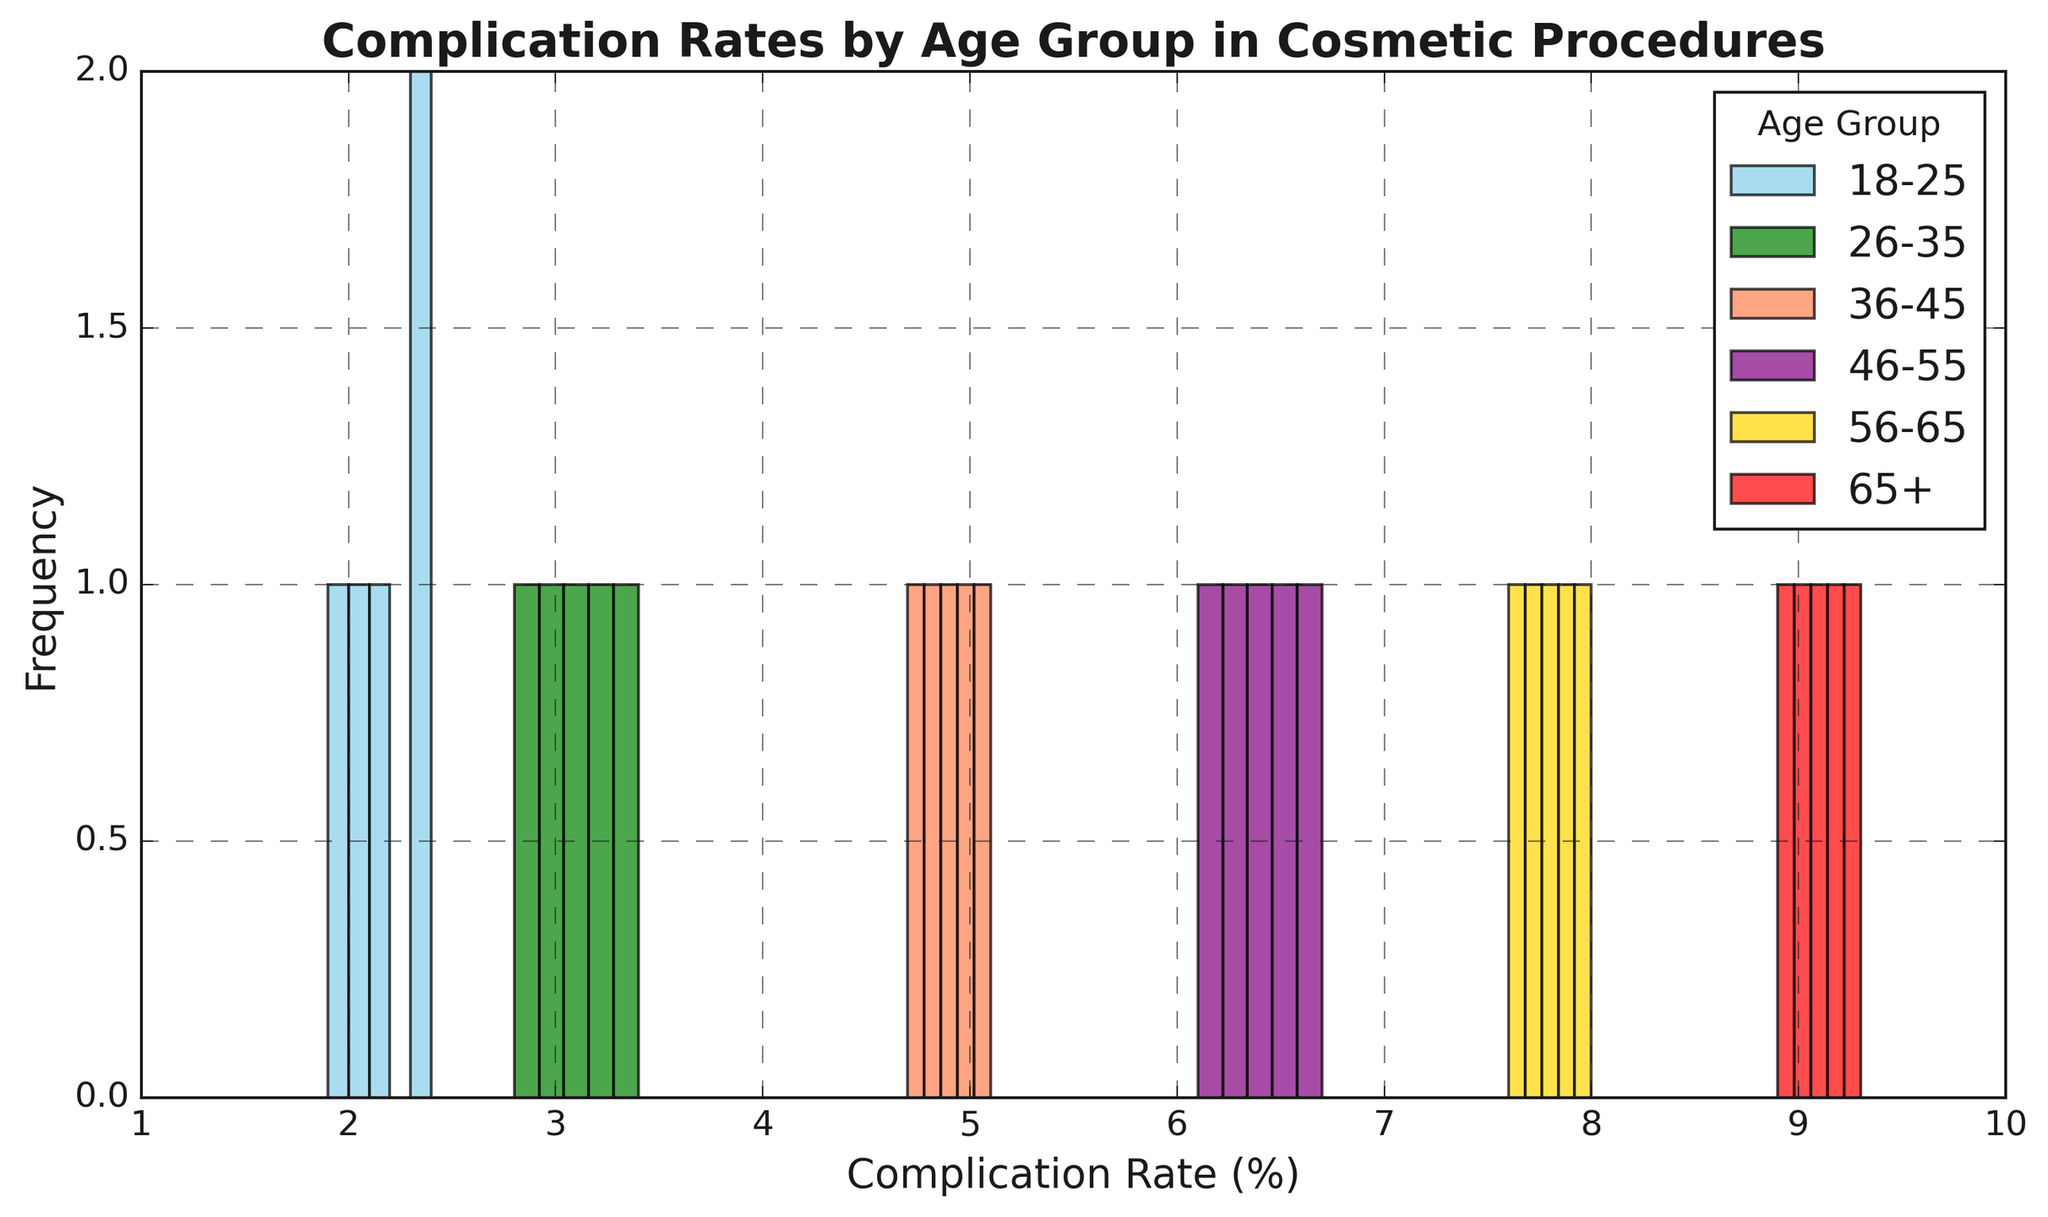What's the most common complication rate for the 26-35 age group? Look at the bins for the green bars in the histogram which represent the 26-35 age group. Identify which bin has the highest frequency.
Answer: 3.0-3.4% How do the complication rates of the 18-25 age group compare to those of the 65+ age group? Compare the skyblue bars for the 18-25 age group with the red bars for the 65+ age group. Notice the max frequency and ranges of the complication rates. 65+ has higher rates and frequencies overall than 18-25.
Answer: The 65+ age group has higher rates What is the range of complication rates for the 46-55 age group? Look at the purple bars for the 46-55 age group and identify the minimum and maximum values on the x-axis where these bars exist.
Answer: 6.1-6.7% Which age group has the highest recorded complication rate? Identify the highest bar across all age groups by comparing their maximum values on the x-axis.
Answer: 65+ Do any age groups have overlapping complication rates, and if so, which ones? Observe the x-axis and see if any of the colored bars extend over the same range. Note the age groups these colors represent.
Answer: Yes, the 56-65 and 65+ age groups overlap What's the average complication rate for the 18-25 age group? Calculate the average complication rate by summing up all the rates for the 18-25 age group [(2.1+2.3+2.4+2.0+1.9)/5 = 2.14%] and divide by the number of rates.
Answer: 2.14% Compare the range of the 18-25 age group's complication rates to the 56-65 age group's complication rates. Identify the minimum and maximum x-axis values for the 18-25 (1.9-2.4%) and 56-65 (7.6-8.0%) age groups and calculate their ranges. The range for 18-25 is 0.5, and for 56-65 is 0.4.
Answer: 18-25: 0.5, 56-65: 0.4 Which age group has the most varied complication rates? Compare the spread of the bars (width of the range) across the x-axis for each age group. The 18-25 age group has the smallest spread, whereas the 65+ age group has the largest.
Answer: 65+ 